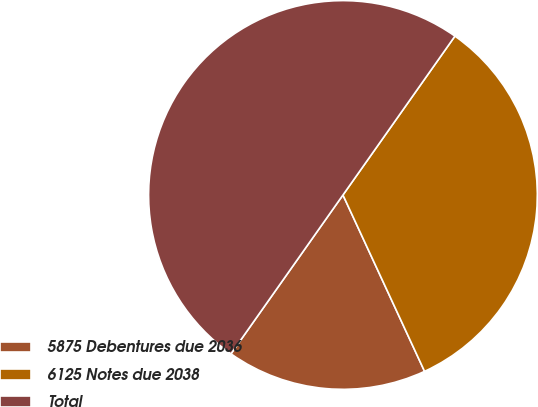<chart> <loc_0><loc_0><loc_500><loc_500><pie_chart><fcel>5875 Debentures due 2036<fcel>6125 Notes due 2038<fcel>Total<nl><fcel>16.67%<fcel>33.33%<fcel>50.0%<nl></chart> 